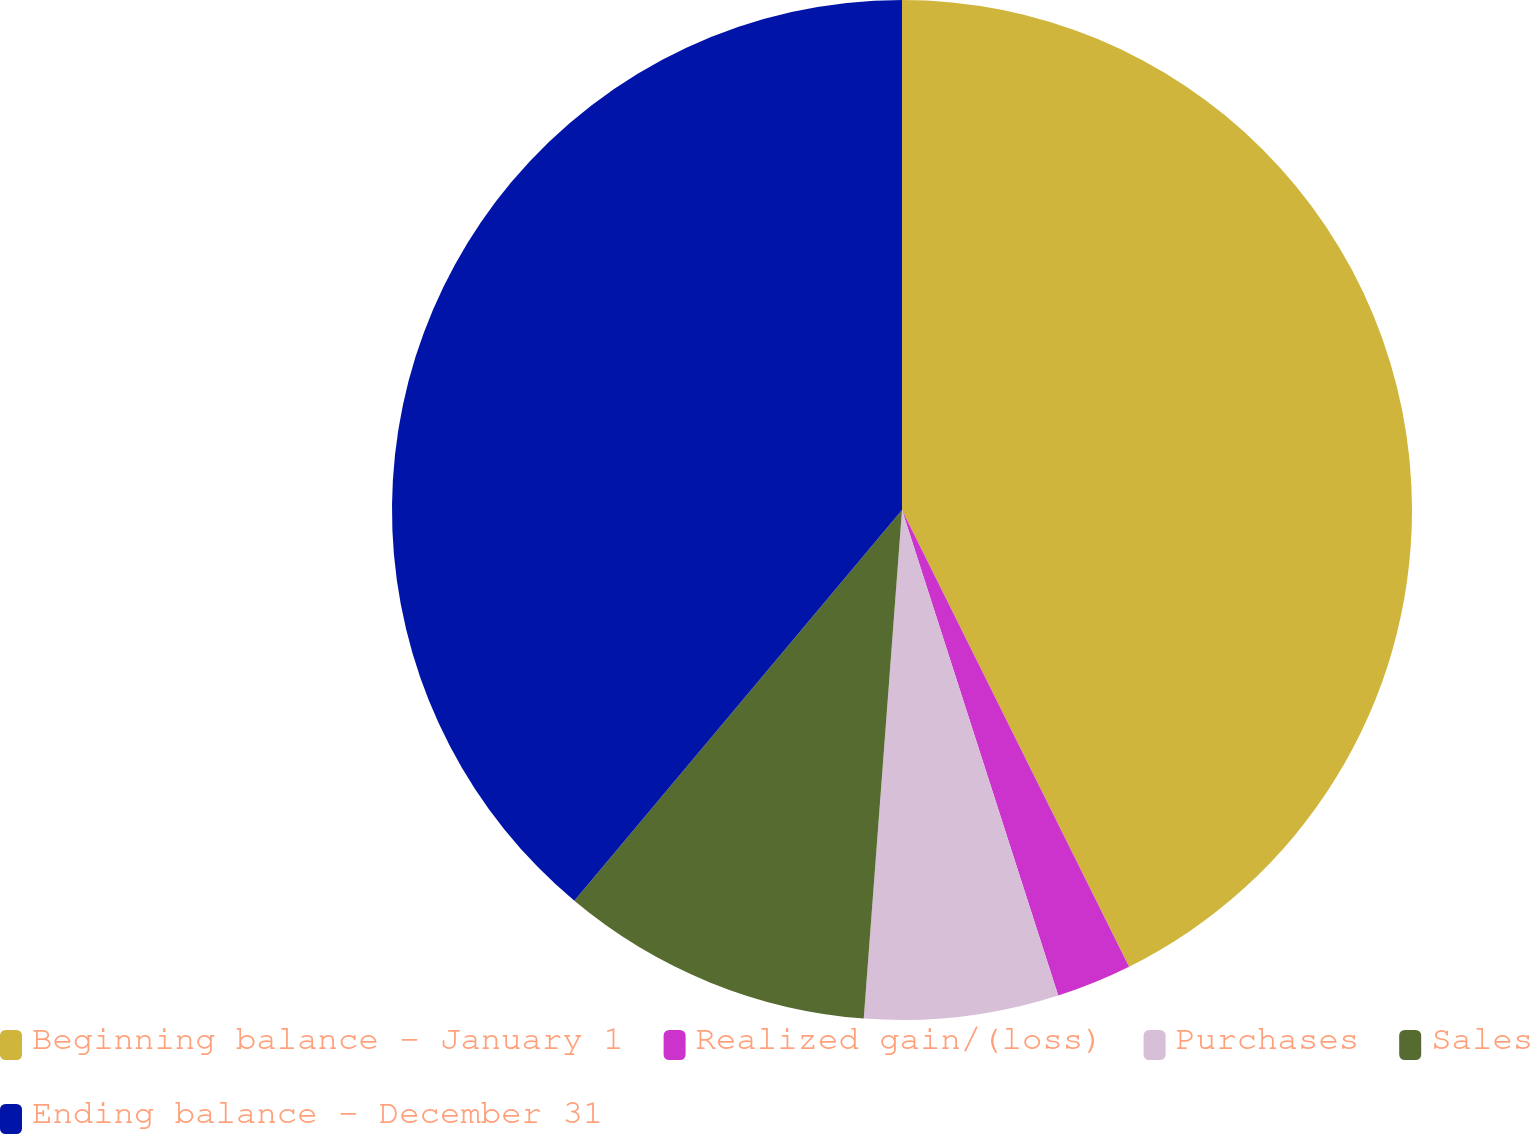<chart> <loc_0><loc_0><loc_500><loc_500><pie_chart><fcel>Beginning balance - January 1<fcel>Realized gain/(loss)<fcel>Purchases<fcel>Sales<fcel>Ending balance - December 31<nl><fcel>42.66%<fcel>2.39%<fcel>6.15%<fcel>9.91%<fcel>38.9%<nl></chart> 